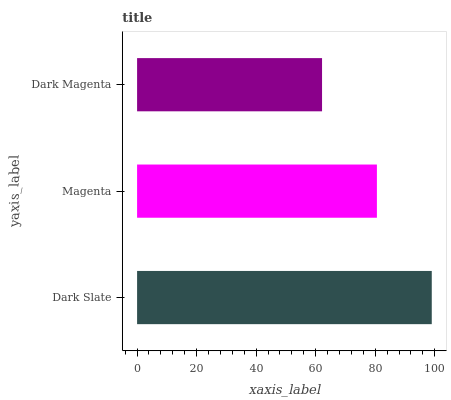Is Dark Magenta the minimum?
Answer yes or no. Yes. Is Dark Slate the maximum?
Answer yes or no. Yes. Is Magenta the minimum?
Answer yes or no. No. Is Magenta the maximum?
Answer yes or no. No. Is Dark Slate greater than Magenta?
Answer yes or no. Yes. Is Magenta less than Dark Slate?
Answer yes or no. Yes. Is Magenta greater than Dark Slate?
Answer yes or no. No. Is Dark Slate less than Magenta?
Answer yes or no. No. Is Magenta the high median?
Answer yes or no. Yes. Is Magenta the low median?
Answer yes or no. Yes. Is Dark Slate the high median?
Answer yes or no. No. Is Dark Magenta the low median?
Answer yes or no. No. 